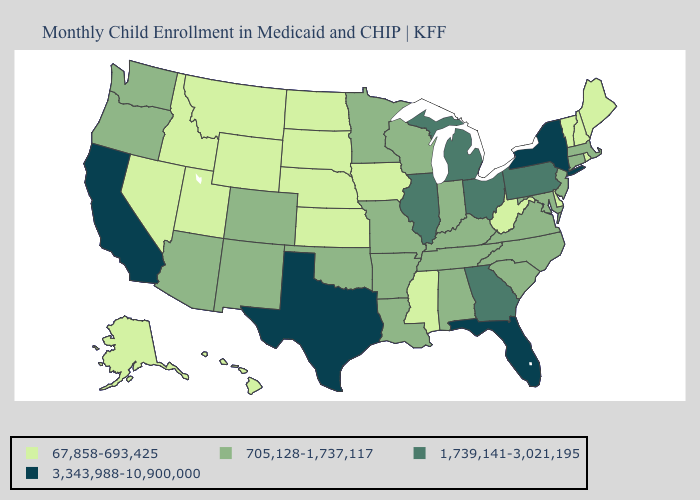What is the highest value in the Northeast ?
Keep it brief. 3,343,988-10,900,000. Does South Dakota have the lowest value in the USA?
Quick response, please. Yes. What is the highest value in the USA?
Be succinct. 3,343,988-10,900,000. Among the states that border Michigan , which have the highest value?
Keep it brief. Ohio. Among the states that border Indiana , does Kentucky have the highest value?
Concise answer only. No. What is the highest value in the MidWest ?
Keep it brief. 1,739,141-3,021,195. What is the value of Texas?
Give a very brief answer. 3,343,988-10,900,000. Which states have the highest value in the USA?
Concise answer only. California, Florida, New York, Texas. What is the lowest value in the USA?
Answer briefly. 67,858-693,425. Does the first symbol in the legend represent the smallest category?
Answer briefly. Yes. How many symbols are there in the legend?
Short answer required. 4. Name the states that have a value in the range 1,739,141-3,021,195?
Short answer required. Georgia, Illinois, Michigan, Ohio, Pennsylvania. Does South Carolina have the lowest value in the South?
Give a very brief answer. No. What is the value of Texas?
Write a very short answer. 3,343,988-10,900,000. 